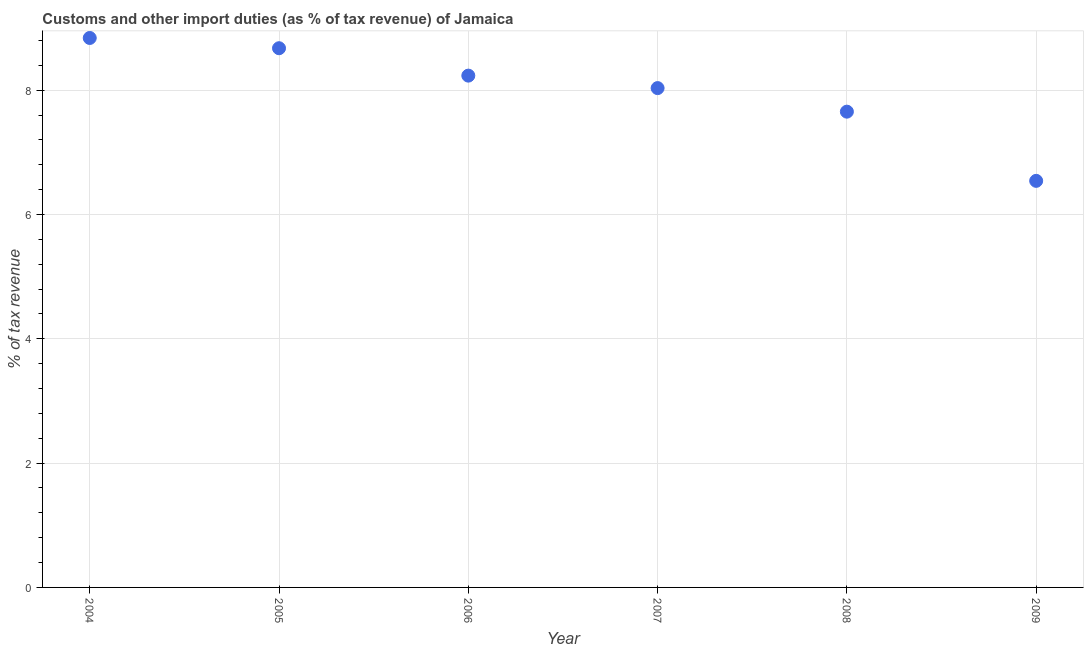What is the customs and other import duties in 2007?
Offer a terse response. 8.03. Across all years, what is the maximum customs and other import duties?
Your answer should be very brief. 8.84. Across all years, what is the minimum customs and other import duties?
Offer a very short reply. 6.54. In which year was the customs and other import duties maximum?
Offer a terse response. 2004. In which year was the customs and other import duties minimum?
Give a very brief answer. 2009. What is the sum of the customs and other import duties?
Your answer should be compact. 47.98. What is the difference between the customs and other import duties in 2006 and 2007?
Ensure brevity in your answer.  0.2. What is the average customs and other import duties per year?
Your response must be concise. 8. What is the median customs and other import duties?
Make the answer very short. 8.13. In how many years, is the customs and other import duties greater than 6.8 %?
Keep it short and to the point. 5. Do a majority of the years between 2007 and 2004 (inclusive) have customs and other import duties greater than 2 %?
Ensure brevity in your answer.  Yes. What is the ratio of the customs and other import duties in 2006 to that in 2008?
Make the answer very short. 1.08. Is the difference between the customs and other import duties in 2007 and 2009 greater than the difference between any two years?
Give a very brief answer. No. What is the difference between the highest and the second highest customs and other import duties?
Ensure brevity in your answer.  0.16. Is the sum of the customs and other import duties in 2004 and 2009 greater than the maximum customs and other import duties across all years?
Your answer should be compact. Yes. What is the difference between the highest and the lowest customs and other import duties?
Make the answer very short. 2.3. Does the customs and other import duties monotonically increase over the years?
Offer a very short reply. No. How many dotlines are there?
Ensure brevity in your answer.  1. What is the difference between two consecutive major ticks on the Y-axis?
Keep it short and to the point. 2. Are the values on the major ticks of Y-axis written in scientific E-notation?
Provide a succinct answer. No. Does the graph contain grids?
Your response must be concise. Yes. What is the title of the graph?
Provide a short and direct response. Customs and other import duties (as % of tax revenue) of Jamaica. What is the label or title of the X-axis?
Provide a succinct answer. Year. What is the label or title of the Y-axis?
Offer a terse response. % of tax revenue. What is the % of tax revenue in 2004?
Offer a terse response. 8.84. What is the % of tax revenue in 2005?
Make the answer very short. 8.68. What is the % of tax revenue in 2006?
Offer a terse response. 8.23. What is the % of tax revenue in 2007?
Make the answer very short. 8.03. What is the % of tax revenue in 2008?
Your answer should be compact. 7.66. What is the % of tax revenue in 2009?
Make the answer very short. 6.54. What is the difference between the % of tax revenue in 2004 and 2005?
Ensure brevity in your answer.  0.16. What is the difference between the % of tax revenue in 2004 and 2006?
Keep it short and to the point. 0.61. What is the difference between the % of tax revenue in 2004 and 2007?
Provide a succinct answer. 0.81. What is the difference between the % of tax revenue in 2004 and 2008?
Offer a terse response. 1.19. What is the difference between the % of tax revenue in 2004 and 2009?
Make the answer very short. 2.3. What is the difference between the % of tax revenue in 2005 and 2006?
Your response must be concise. 0.44. What is the difference between the % of tax revenue in 2005 and 2007?
Your answer should be compact. 0.64. What is the difference between the % of tax revenue in 2005 and 2008?
Provide a succinct answer. 1.02. What is the difference between the % of tax revenue in 2005 and 2009?
Your response must be concise. 2.13. What is the difference between the % of tax revenue in 2006 and 2007?
Your answer should be compact. 0.2. What is the difference between the % of tax revenue in 2006 and 2008?
Your answer should be very brief. 0.58. What is the difference between the % of tax revenue in 2006 and 2009?
Provide a short and direct response. 1.69. What is the difference between the % of tax revenue in 2007 and 2008?
Offer a very short reply. 0.38. What is the difference between the % of tax revenue in 2007 and 2009?
Give a very brief answer. 1.49. What is the difference between the % of tax revenue in 2008 and 2009?
Offer a very short reply. 1.11. What is the ratio of the % of tax revenue in 2004 to that in 2006?
Provide a short and direct response. 1.07. What is the ratio of the % of tax revenue in 2004 to that in 2008?
Your answer should be compact. 1.16. What is the ratio of the % of tax revenue in 2004 to that in 2009?
Your response must be concise. 1.35. What is the ratio of the % of tax revenue in 2005 to that in 2006?
Provide a succinct answer. 1.05. What is the ratio of the % of tax revenue in 2005 to that in 2007?
Offer a very short reply. 1.08. What is the ratio of the % of tax revenue in 2005 to that in 2008?
Give a very brief answer. 1.13. What is the ratio of the % of tax revenue in 2005 to that in 2009?
Your answer should be very brief. 1.33. What is the ratio of the % of tax revenue in 2006 to that in 2008?
Keep it short and to the point. 1.08. What is the ratio of the % of tax revenue in 2006 to that in 2009?
Your answer should be very brief. 1.26. What is the ratio of the % of tax revenue in 2007 to that in 2008?
Your answer should be compact. 1.05. What is the ratio of the % of tax revenue in 2007 to that in 2009?
Make the answer very short. 1.23. What is the ratio of the % of tax revenue in 2008 to that in 2009?
Your answer should be very brief. 1.17. 